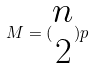<formula> <loc_0><loc_0><loc_500><loc_500>M = ( \begin{matrix} n \\ 2 \end{matrix} ) p</formula> 